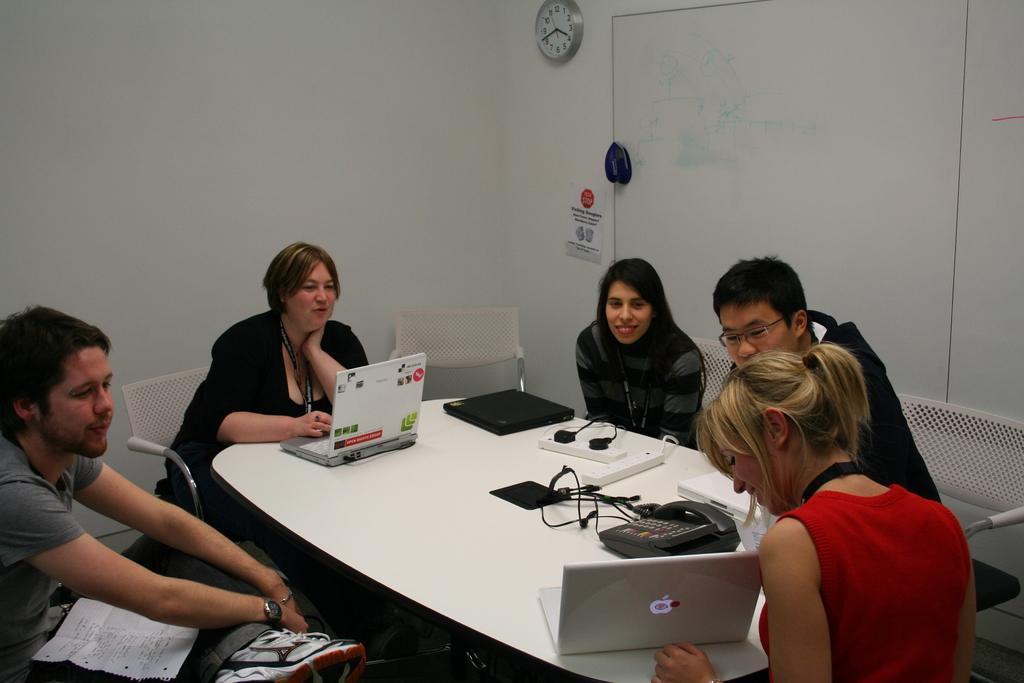Please provide a concise description of this image. In this image I can see the group of sitting in-front of the table. On the table there are laptops and the telephone. To the wall there is a clock. 